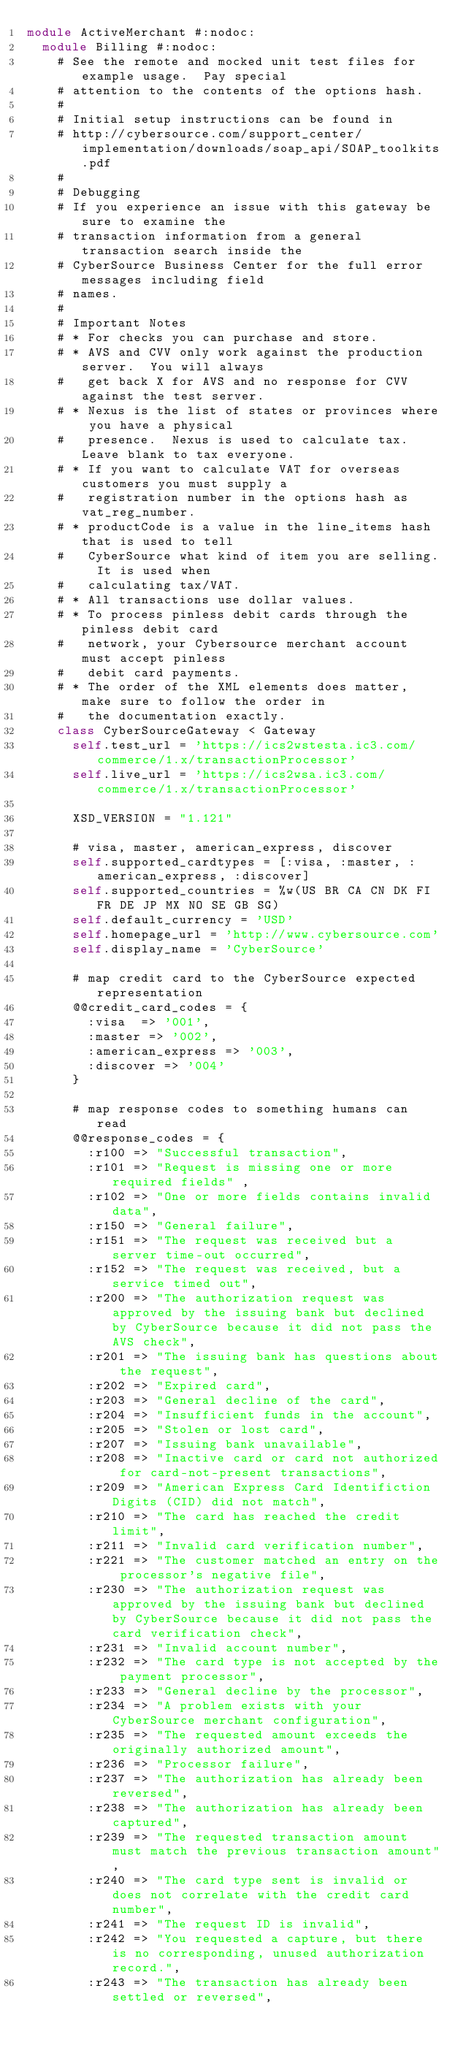<code> <loc_0><loc_0><loc_500><loc_500><_Ruby_>module ActiveMerchant #:nodoc:
  module Billing #:nodoc:
    # See the remote and mocked unit test files for example usage.  Pay special
    # attention to the contents of the options hash.
    #
    # Initial setup instructions can be found in
    # http://cybersource.com/support_center/implementation/downloads/soap_api/SOAP_toolkits.pdf
    #
    # Debugging
    # If you experience an issue with this gateway be sure to examine the
    # transaction information from a general transaction search inside the
    # CyberSource Business Center for the full error messages including field
    # names.
    #
    # Important Notes
    # * For checks you can purchase and store.
    # * AVS and CVV only work against the production server.  You will always
    #   get back X for AVS and no response for CVV against the test server.
    # * Nexus is the list of states or provinces where you have a physical
    #   presence.  Nexus is used to calculate tax.  Leave blank to tax everyone.
    # * If you want to calculate VAT for overseas customers you must supply a
    #   registration number in the options hash as vat_reg_number.
    # * productCode is a value in the line_items hash that is used to tell
    #   CyberSource what kind of item you are selling.  It is used when
    #   calculating tax/VAT.
    # * All transactions use dollar values.
    # * To process pinless debit cards through the pinless debit card
    #   network, your Cybersource merchant account must accept pinless
    #   debit card payments.
    # * The order of the XML elements does matter, make sure to follow the order in
    #   the documentation exactly.
    class CyberSourceGateway < Gateway
      self.test_url = 'https://ics2wstesta.ic3.com/commerce/1.x/transactionProcessor'
      self.live_url = 'https://ics2wsa.ic3.com/commerce/1.x/transactionProcessor'

      XSD_VERSION = "1.121"

      # visa, master, american_express, discover
      self.supported_cardtypes = [:visa, :master, :american_express, :discover]
      self.supported_countries = %w(US BR CA CN DK FI FR DE JP MX NO SE GB SG)
      self.default_currency = 'USD'
      self.homepage_url = 'http://www.cybersource.com'
      self.display_name = 'CyberSource'

      # map credit card to the CyberSource expected representation
      @@credit_card_codes = {
        :visa  => '001',
        :master => '002',
        :american_express => '003',
        :discover => '004'
      }

      # map response codes to something humans can read
      @@response_codes = {
        :r100 => "Successful transaction",
        :r101 => "Request is missing one or more required fields" ,
        :r102 => "One or more fields contains invalid data",
        :r150 => "General failure",
        :r151 => "The request was received but a server time-out occurred",
        :r152 => "The request was received, but a service timed out",
        :r200 => "The authorization request was approved by the issuing bank but declined by CyberSource because it did not pass the AVS check",
        :r201 => "The issuing bank has questions about the request",
        :r202 => "Expired card",
        :r203 => "General decline of the card",
        :r204 => "Insufficient funds in the account",
        :r205 => "Stolen or lost card",
        :r207 => "Issuing bank unavailable",
        :r208 => "Inactive card or card not authorized for card-not-present transactions",
        :r209 => "American Express Card Identifiction Digits (CID) did not match",
        :r210 => "The card has reached the credit limit",
        :r211 => "Invalid card verification number",
        :r221 => "The customer matched an entry on the processor's negative file",
        :r230 => "The authorization request was approved by the issuing bank but declined by CyberSource because it did not pass the card verification check",
        :r231 => "Invalid account number",
        :r232 => "The card type is not accepted by the payment processor",
        :r233 => "General decline by the processor",
        :r234 => "A problem exists with your CyberSource merchant configuration",
        :r235 => "The requested amount exceeds the originally authorized amount",
        :r236 => "Processor failure",
        :r237 => "The authorization has already been reversed",
        :r238 => "The authorization has already been captured",
        :r239 => "The requested transaction amount must match the previous transaction amount",
        :r240 => "The card type sent is invalid or does not correlate with the credit card number",
        :r241 => "The request ID is invalid",
        :r242 => "You requested a capture, but there is no corresponding, unused authorization record.",
        :r243 => "The transaction has already been settled or reversed",</code> 